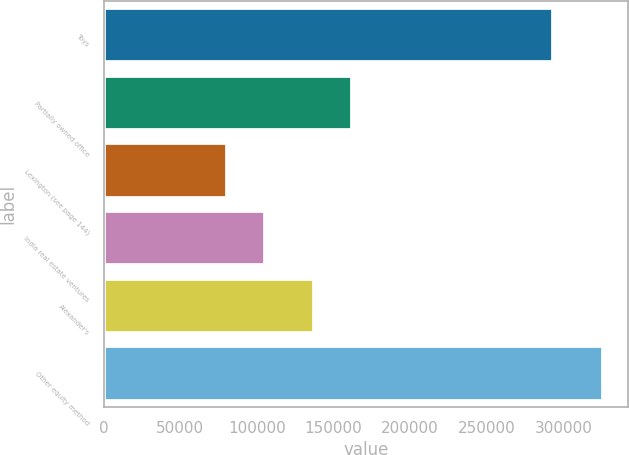Convert chart to OTSL. <chart><loc_0><loc_0><loc_500><loc_500><bar_chart><fcel>Toys<fcel>Partially owned office<fcel>Lexington (see page 144)<fcel>India real estate ventures<fcel>Alexander's<fcel>Other equity method<nl><fcel>293096<fcel>161808<fcel>80748<fcel>105251<fcel>137305<fcel>325775<nl></chart> 